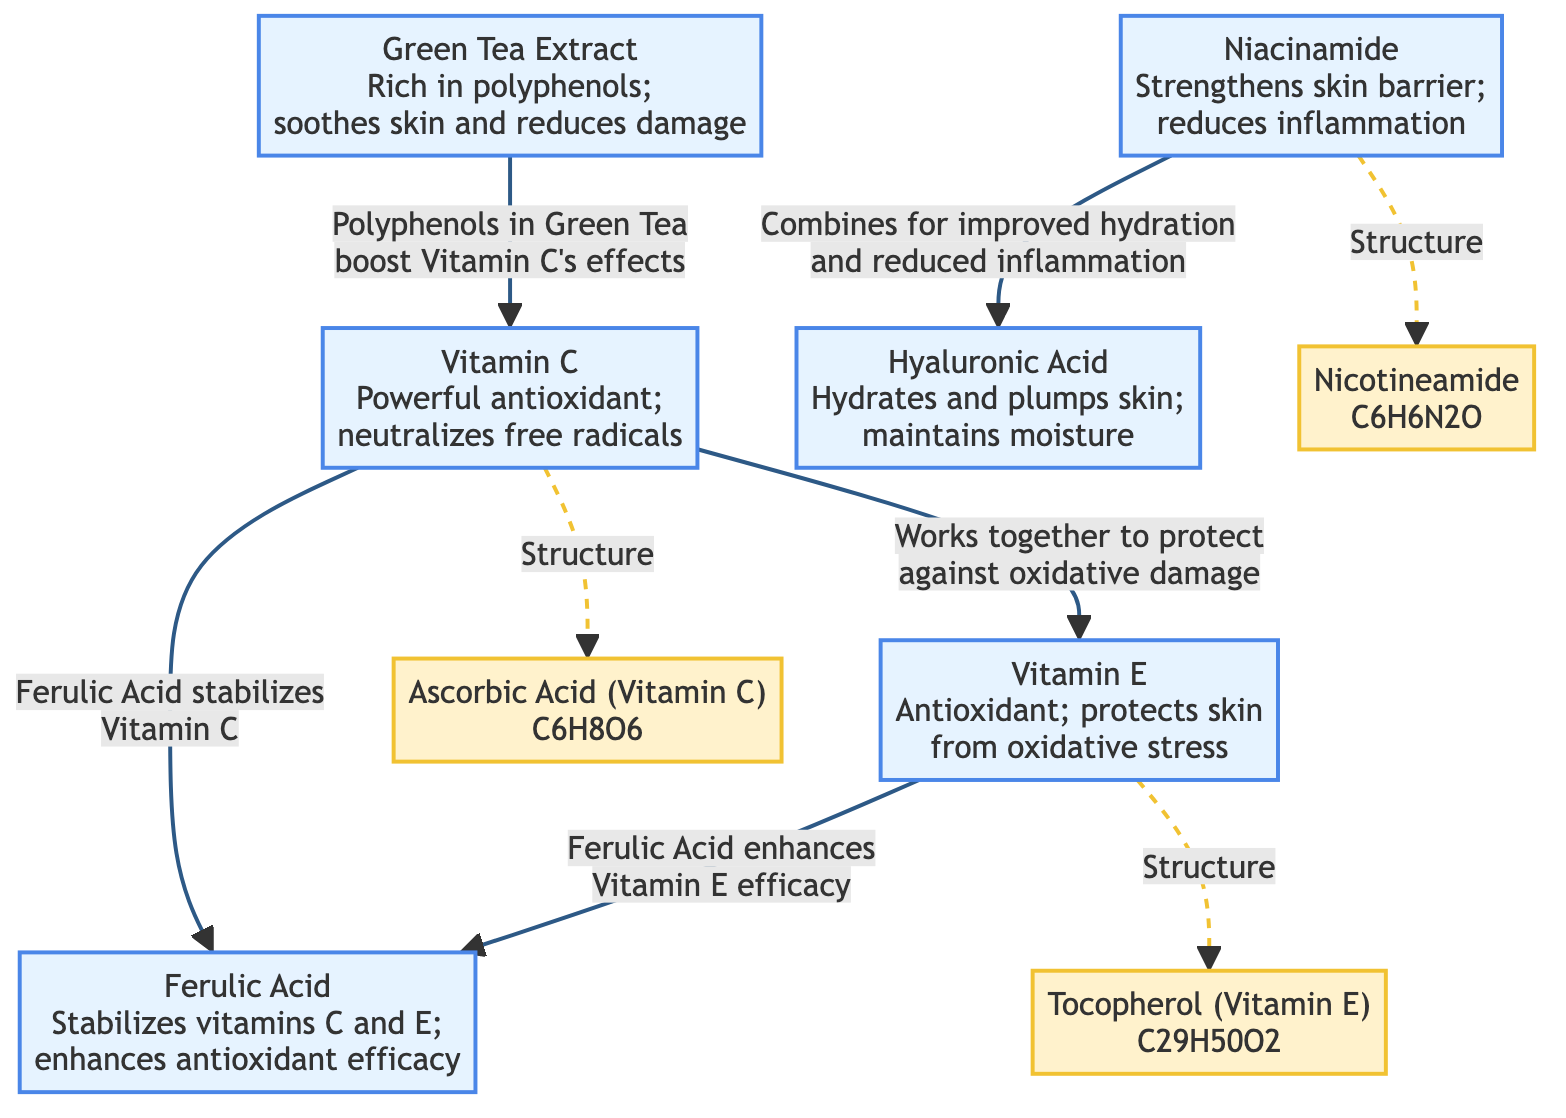What are the chemical structures present in this diagram? The diagram lists three chemical structures: Ascorbic Acid (Vitamin C), Tocopherol (Vitamin E), and Nicotinamide. Each has a corresponding chemical formula displayed in the diagram.
Answer: Ascorbic Acid, Tocopherol, Nicotinamide How many active ingredients are depicted in this diagram? By counting the nodes labeled as active ingredients—Vitamin C, Vitamin E, Niacinamide, Green Tea Extract, Hyaluronic Acid, and Ferulic Acid—there are six distinct active ingredients represented.
Answer: 6 Which ingredient stabilizes Vitamin C in the diagram? The diagram specifies that Ferulic Acid stabilizes Vitamin C, which is indicated by the directed arrow connecting these two nodes.
Answer: Ferulic Acid What beneficial effect does Green Tea Extract have on Vitamin C? The diagram states that the polyphenols in Green Tea Extract boost Vitamin C's effects, linking the two ingredients in their synergistic effects against pollutants.
Answer: Boost Vitamin C's effects Which two ingredients combine for improved hydration and reduced inflammation? The diagram clearly shows a connection between Niacinamide and Hyaluronic Acid indicating that these two ingredients work together to enhance hydration and lessen inflammation.
Answer: Niacinamide and Hyaluronic Acid How does Vitamin E's effectiveness improve according to the diagram? The diagram points out that Ferulic Acid enhances the efficacy of Vitamin E, which is represented by the arrow going from Ferulic Acid to Vitamin E.
Answer: Enhanced by Ferulic Acid What is mentioned as Vitamin C's primary function? The diagram describes Vitamin C as a powerful antioxidant that neutralizes free radicals, highlighting its role in protecting the skin.
Answer: Powerful antioxidant What interaction does Hyaluronic Acid have with Niacinamide as per the diagram? The diagram indicates a direct connection between Hyaluronic Acid and Niacinamide, emphasizing their combined action for better hydration and reduced skin inflammation.
Answer: Combines for improved hydration and reduced inflammation 